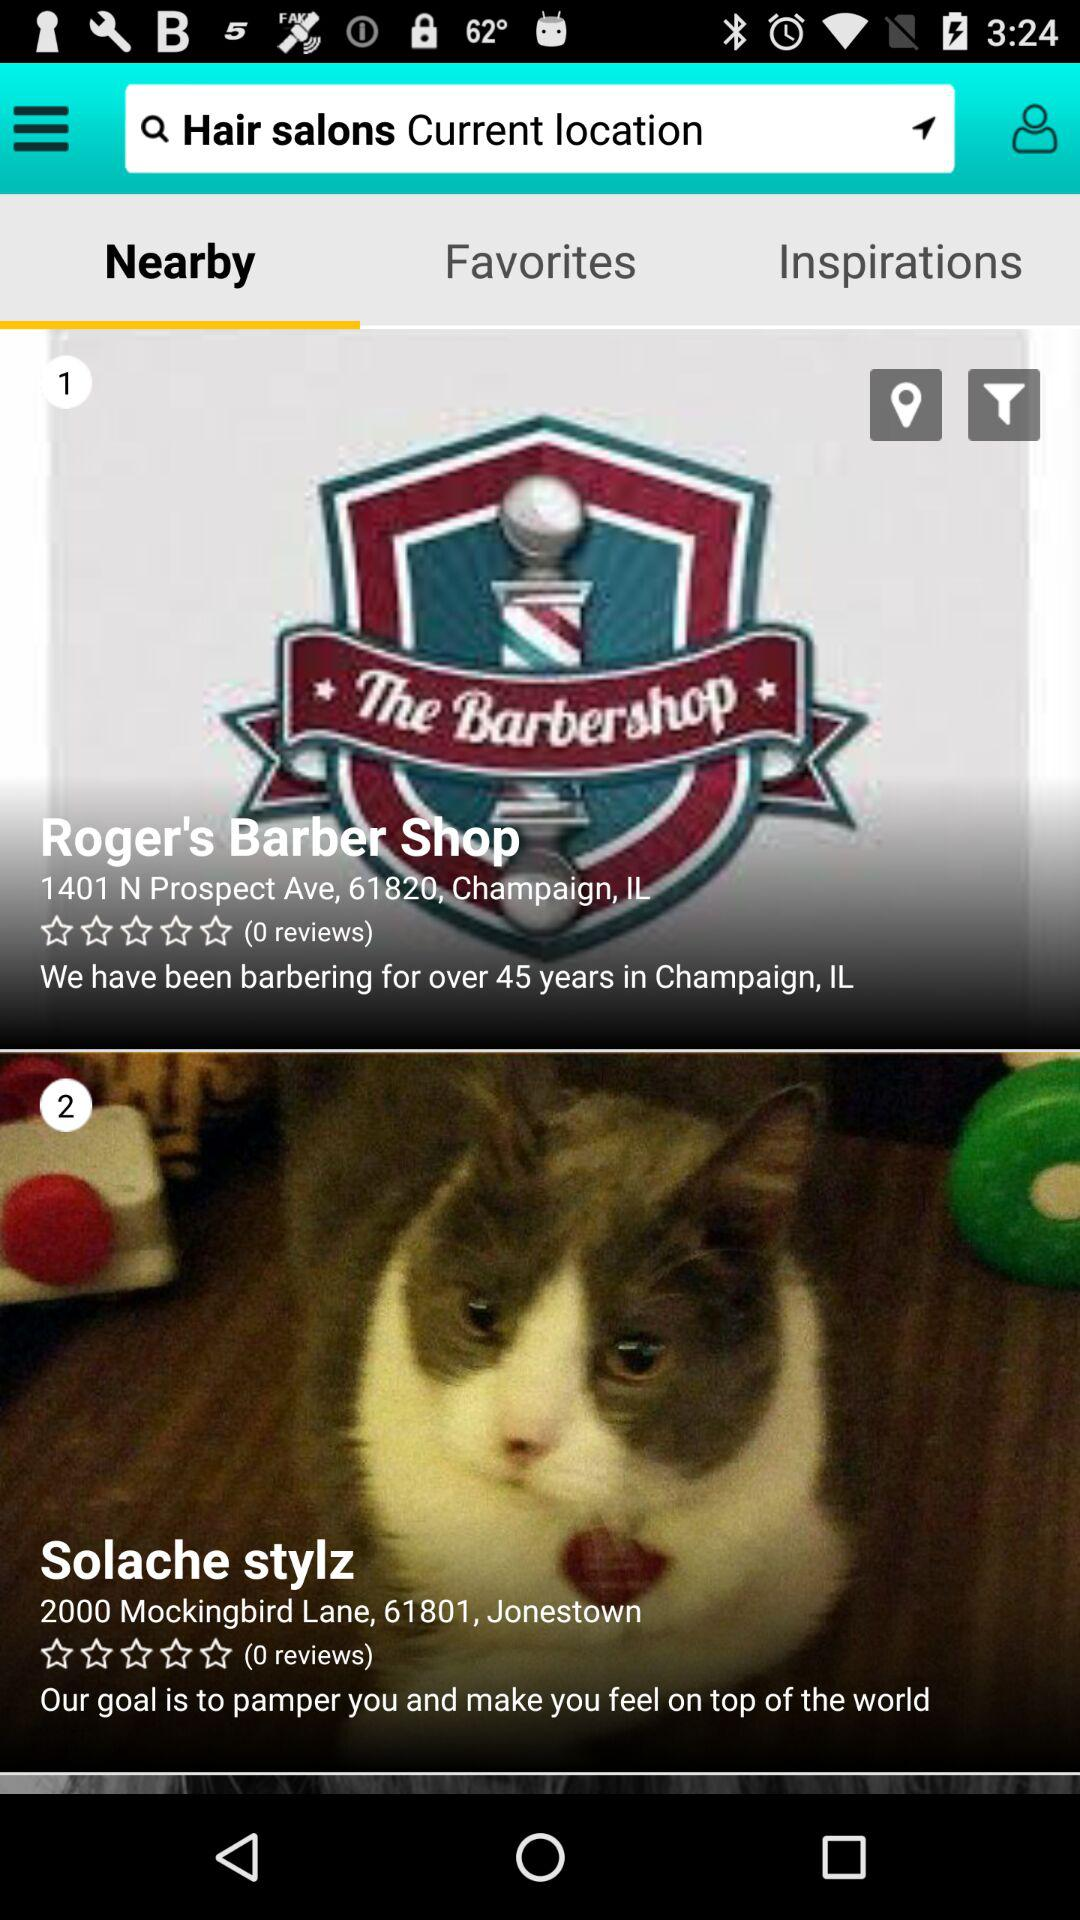What is the rating of Solache stylz? The rating is 0 stars. 